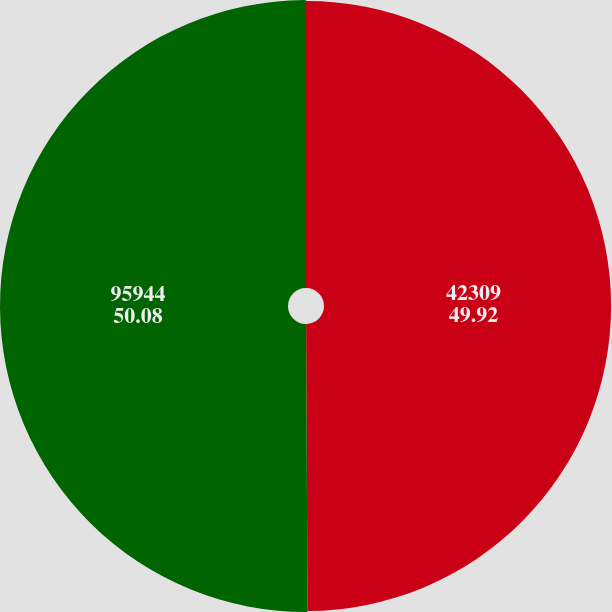<chart> <loc_0><loc_0><loc_500><loc_500><pie_chart><fcel>42309<fcel>95944<nl><fcel>49.92%<fcel>50.08%<nl></chart> 